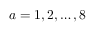Convert formula to latex. <formula><loc_0><loc_0><loc_500><loc_500>a = 1 , 2 , \dots , 8</formula> 